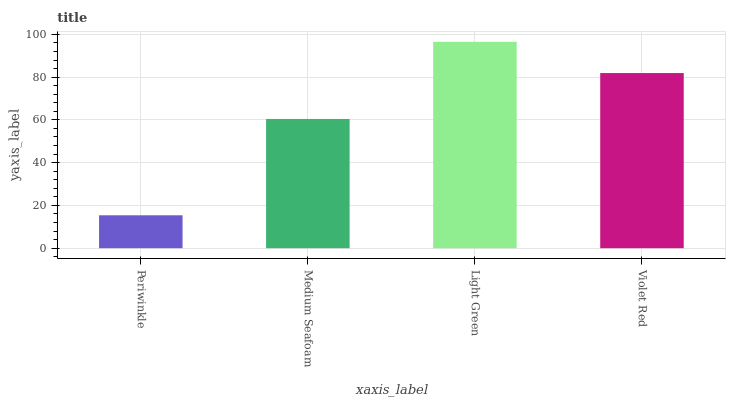Is Periwinkle the minimum?
Answer yes or no. Yes. Is Light Green the maximum?
Answer yes or no. Yes. Is Medium Seafoam the minimum?
Answer yes or no. No. Is Medium Seafoam the maximum?
Answer yes or no. No. Is Medium Seafoam greater than Periwinkle?
Answer yes or no. Yes. Is Periwinkle less than Medium Seafoam?
Answer yes or no. Yes. Is Periwinkle greater than Medium Seafoam?
Answer yes or no. No. Is Medium Seafoam less than Periwinkle?
Answer yes or no. No. Is Violet Red the high median?
Answer yes or no. Yes. Is Medium Seafoam the low median?
Answer yes or no. Yes. Is Light Green the high median?
Answer yes or no. No. Is Periwinkle the low median?
Answer yes or no. No. 